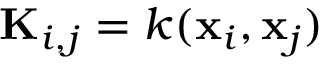Convert formula to latex. <formula><loc_0><loc_0><loc_500><loc_500>K _ { i , j } = k ( x _ { i } , x _ { j } )</formula> 